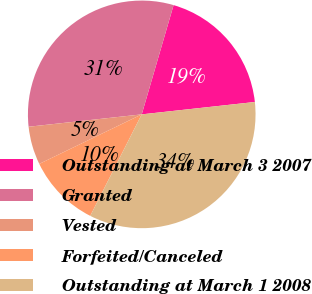Convert chart to OTSL. <chart><loc_0><loc_0><loc_500><loc_500><pie_chart><fcel>Outstanding at March 3 2007<fcel>Granted<fcel>Vested<fcel>Forfeited/Canceled<fcel>Outstanding at March 1 2008<nl><fcel>18.75%<fcel>31.25%<fcel>5.43%<fcel>10.36%<fcel>34.21%<nl></chart> 